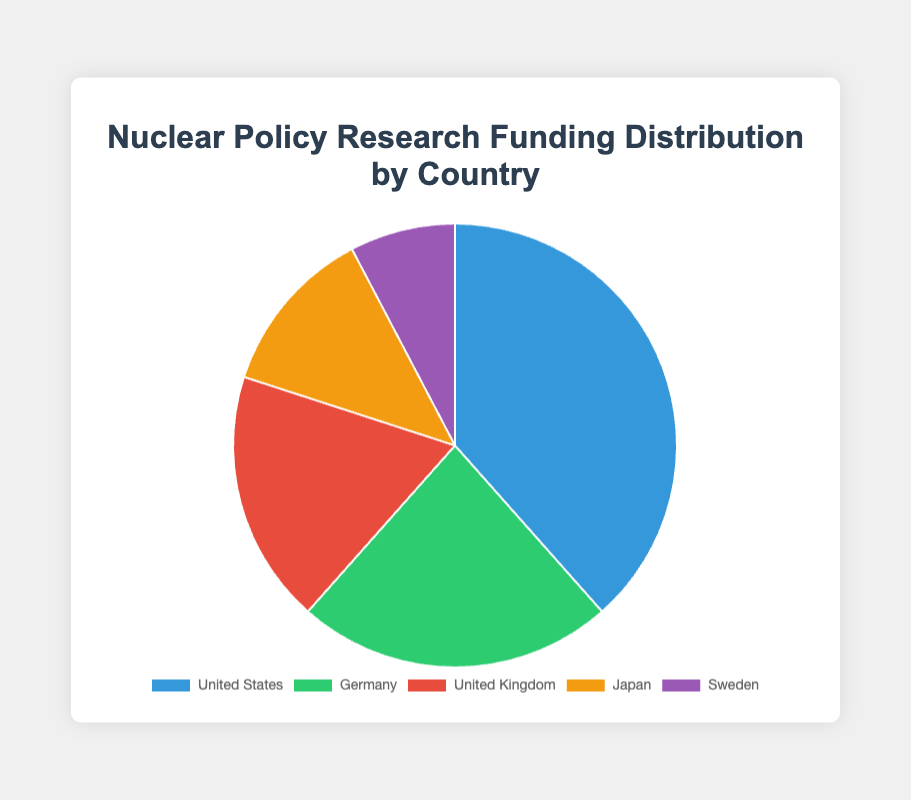What is the total funding amount represented in the pie chart? To determine the total funding, sum the individual amounts from each country. The funding amounts are $25,000,000 (United States), $15,000,000 (Germany), $12,000,000 (United Kingdom), $8,000,000 (Japan), and $5,000,000 (Sweden). The total is 25,000,000 + 15,000,000 + 12,000,000 + 8,000,000 + 5,000,000 = $65,000,000.
Answer: $65,000,000 Which country provides the highest funding for nuclear policy research? By visually inspecting the pie chart, the largest segment represents the United States, indicating it provides the highest funding amount.
Answer: United States How does the funding amount from Japan compare to that from Sweden? According to the pie chart, Japan's funding amount is $8,000,000, and Sweden's is $5,000,000. Therefore, Japan's funding is greater than Sweden's.
Answer: Japan's funding is greater What percentage of the total funding does Germany contribute? First, calculate the total funding, which is $65,000,000. Germany contributes $15,000,000. To find the percentage, use the formula: ($15,000,000 / $65,000,000) * 100%. This equals approximately 23.08%.
Answer: Approximately 23.08% What is the difference in funding amounts between the United Kingdom and Japan? The pie chart shows that the United Kingdom provides $12,000,000, and Japan provides $8,000,000. The difference is $12,000,000 - $8,000,000 = $4,000,000.
Answer: $4,000,000 What are the funding contributions (in USD) of the countries represented by the darkest and lightest colors in the chart? Visually inspect the pie chart for the darkest and lightest colors. Assume the darkest color represents the United States ($25,000,000) and the lightest color represents Sweden ($5,000,000).
Answer: $25,000,000 (United States) and $5,000,000 (Sweden) What is the median funding amount among the five countries? List the funding amounts in ascending order: $5,000,000 (Sweden), $8,000,000 (Japan), $12,000,000 (United Kingdom), $15,000,000 (Germany), and $25,000,000 (United States). The median is the middle value, which is $12,000,000.
Answer: $12,000,000 If the funding provided by the United States were to increase by 20%, what would be the new total funding? First, calculate the increase: 20% of $25,000,000 is (0.20 * 25,000,000 = $5,000,000). Add this increase to the original amount: $25,000,000 + $5,000,000 = $30,000,000. Then, compute the new total funding: $65,000,000 (original total) - $25,000,000 (original US funding) + $30,000,000 (new US funding) = $70,000,000.
Answer: $70,000,000 